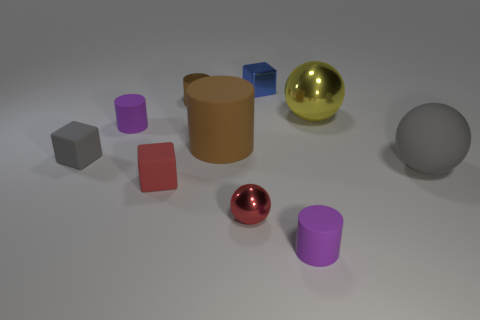Is the size of the red block the same as the gray rubber thing to the left of the rubber ball?
Keep it short and to the point. Yes. Is there a red matte object that is in front of the small purple cylinder on the right side of the blue metallic cube?
Make the answer very short. No. There is a tiny metal object that is in front of the small brown thing; what shape is it?
Offer a terse response. Sphere. There is a block that is the same color as the big rubber sphere; what is its material?
Offer a terse response. Rubber. What is the color of the tiny matte cylinder that is to the left of the cylinder behind the large yellow sphere?
Your answer should be very brief. Purple. Is the blue metallic thing the same size as the gray matte sphere?
Offer a very short reply. No. There is a small brown object that is the same shape as the large brown rubber thing; what is its material?
Offer a terse response. Metal. What number of blue cubes are the same size as the yellow sphere?
Your answer should be very brief. 0. There is a block that is the same material as the small red ball; what is its color?
Make the answer very short. Blue. Are there fewer shiny things than large yellow metallic spheres?
Give a very brief answer. No. 